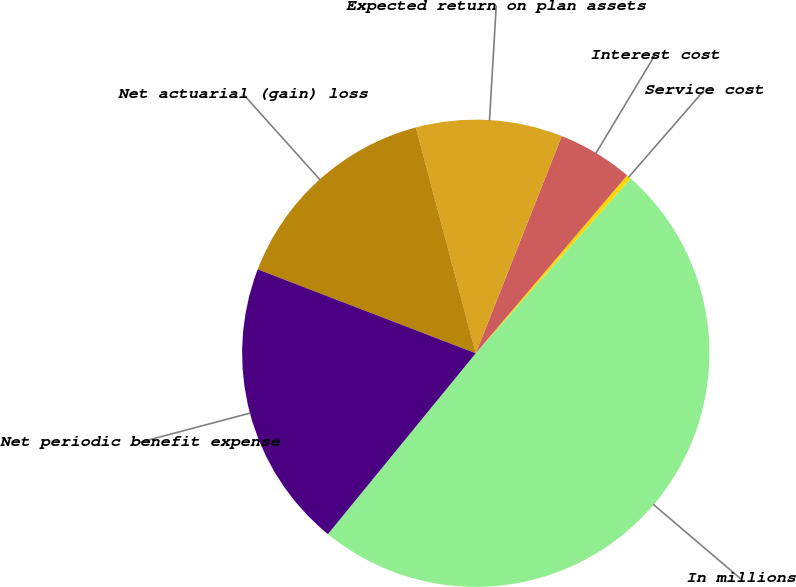Convert chart to OTSL. <chart><loc_0><loc_0><loc_500><loc_500><pie_chart><fcel>In millions<fcel>Service cost<fcel>Interest cost<fcel>Expected return on plan assets<fcel>Net actuarial (gain) loss<fcel>Net periodic benefit expense<nl><fcel>49.37%<fcel>0.32%<fcel>5.22%<fcel>10.13%<fcel>15.03%<fcel>19.94%<nl></chart> 